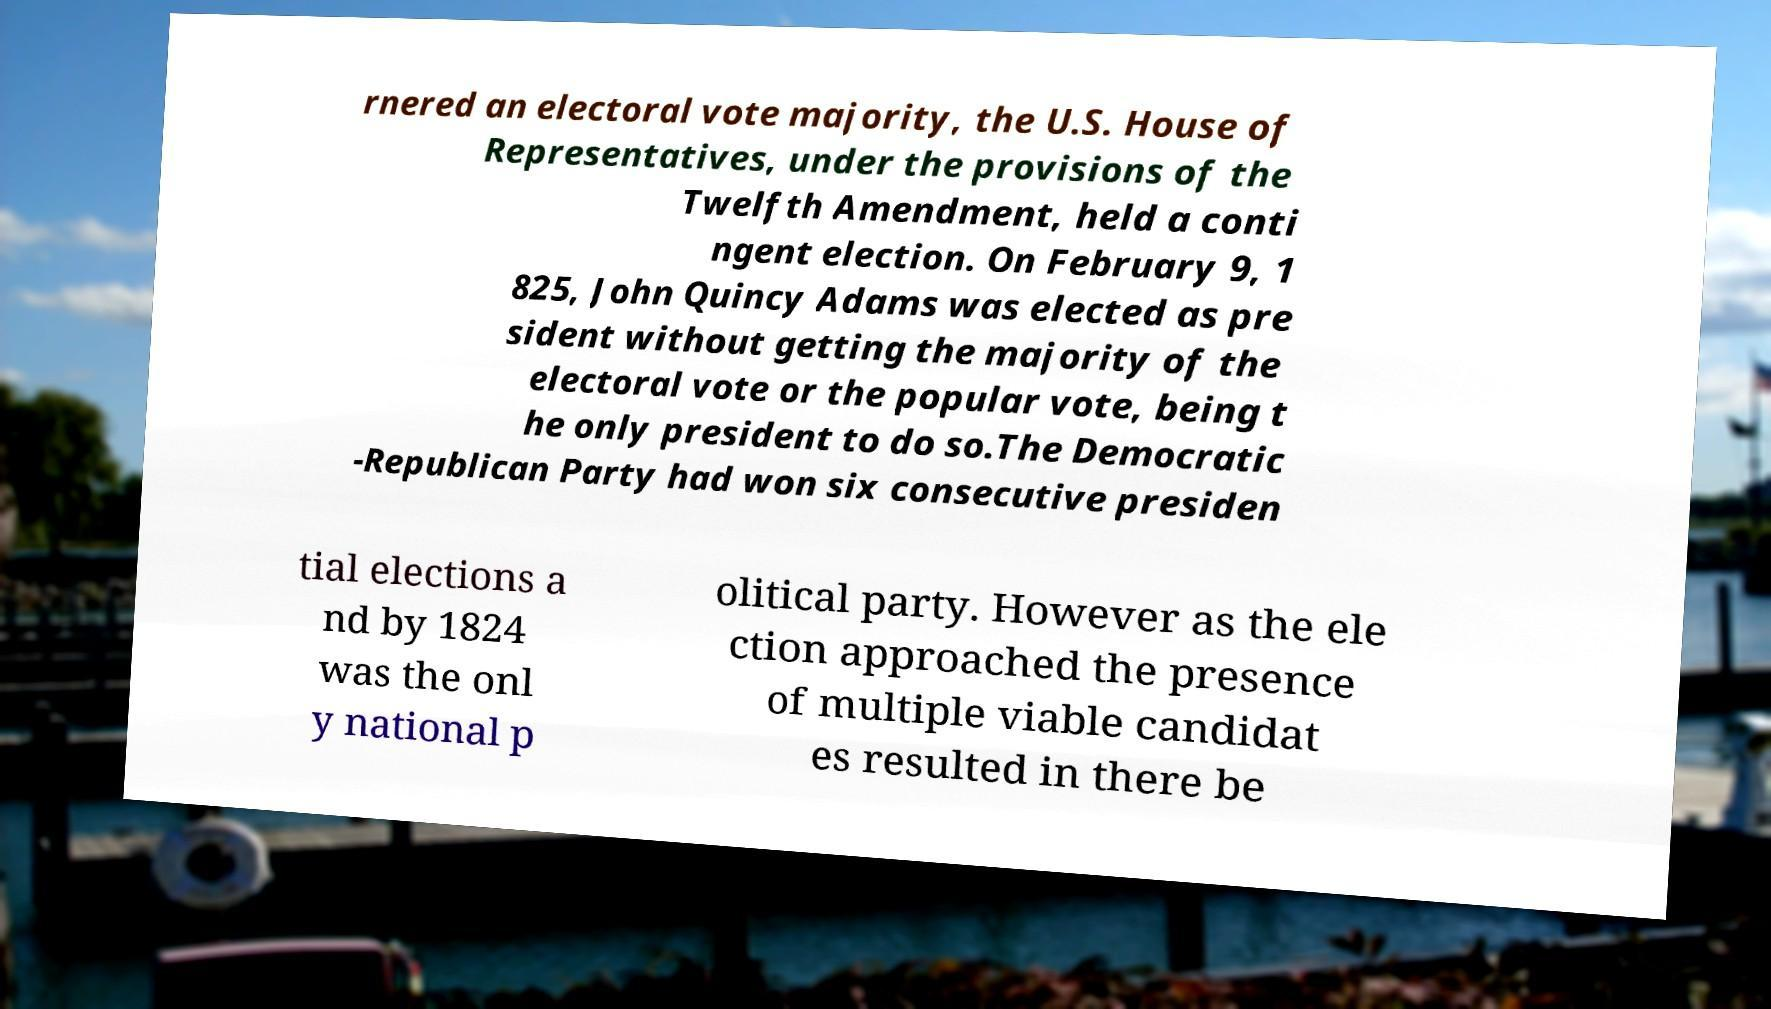There's text embedded in this image that I need extracted. Can you transcribe it verbatim? rnered an electoral vote majority, the U.S. House of Representatives, under the provisions of the Twelfth Amendment, held a conti ngent election. On February 9, 1 825, John Quincy Adams was elected as pre sident without getting the majority of the electoral vote or the popular vote, being t he only president to do so.The Democratic -Republican Party had won six consecutive presiden tial elections a nd by 1824 was the onl y national p olitical party. However as the ele ction approached the presence of multiple viable candidat es resulted in there be 